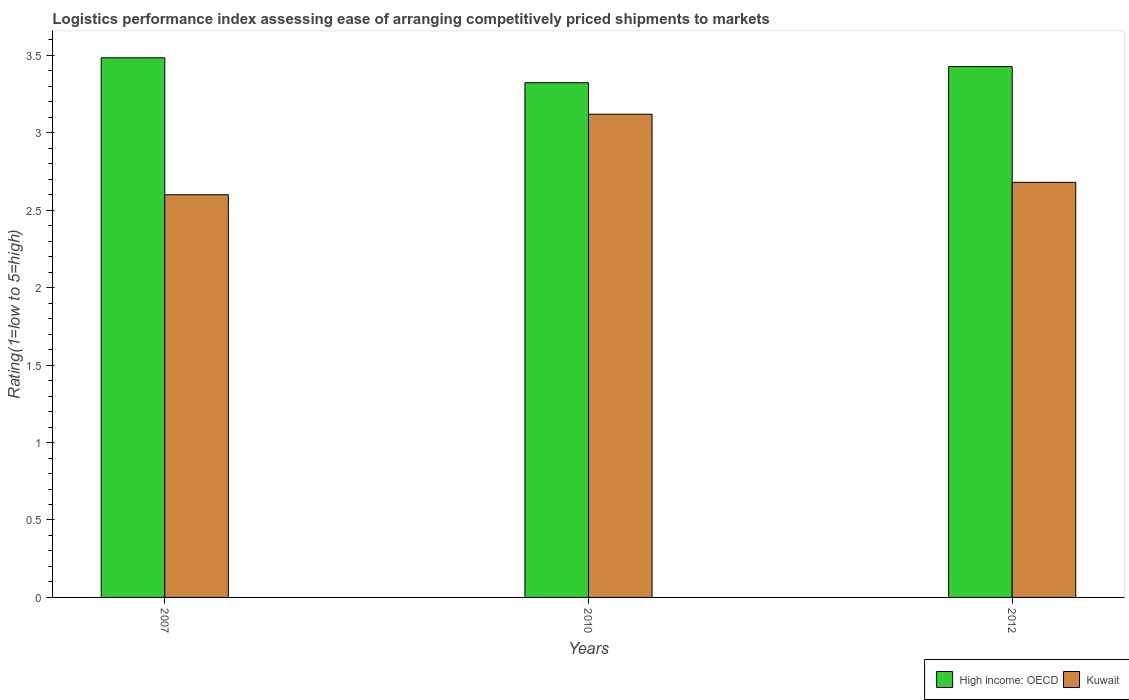How many different coloured bars are there?
Make the answer very short. 2. How many groups of bars are there?
Provide a succinct answer. 3. How many bars are there on the 2nd tick from the left?
Your answer should be compact. 2. How many bars are there on the 3rd tick from the right?
Ensure brevity in your answer.  2. In how many cases, is the number of bars for a given year not equal to the number of legend labels?
Your answer should be compact. 0. What is the Logistic performance index in High income: OECD in 2010?
Give a very brief answer. 3.32. Across all years, what is the maximum Logistic performance index in Kuwait?
Your answer should be very brief. 3.12. Across all years, what is the minimum Logistic performance index in High income: OECD?
Give a very brief answer. 3.32. In which year was the Logistic performance index in High income: OECD minimum?
Make the answer very short. 2010. What is the total Logistic performance index in High income: OECD in the graph?
Your response must be concise. 10.24. What is the difference between the Logistic performance index in High income: OECD in 2007 and that in 2012?
Your answer should be compact. 0.06. What is the difference between the Logistic performance index in High income: OECD in 2010 and the Logistic performance index in Kuwait in 2012?
Keep it short and to the point. 0.64. What is the average Logistic performance index in High income: OECD per year?
Make the answer very short. 3.41. In the year 2007, what is the difference between the Logistic performance index in Kuwait and Logistic performance index in High income: OECD?
Give a very brief answer. -0.88. In how many years, is the Logistic performance index in Kuwait greater than 2.5?
Offer a very short reply. 3. What is the ratio of the Logistic performance index in High income: OECD in 2010 to that in 2012?
Provide a short and direct response. 0.97. Is the Logistic performance index in High income: OECD in 2010 less than that in 2012?
Keep it short and to the point. Yes. What is the difference between the highest and the second highest Logistic performance index in Kuwait?
Make the answer very short. 0.44. What is the difference between the highest and the lowest Logistic performance index in Kuwait?
Offer a terse response. 0.52. In how many years, is the Logistic performance index in High income: OECD greater than the average Logistic performance index in High income: OECD taken over all years?
Provide a succinct answer. 2. Is the sum of the Logistic performance index in High income: OECD in 2010 and 2012 greater than the maximum Logistic performance index in Kuwait across all years?
Ensure brevity in your answer.  Yes. What does the 1st bar from the left in 2012 represents?
Your answer should be very brief. High income: OECD. What does the 1st bar from the right in 2010 represents?
Offer a terse response. Kuwait. How many bars are there?
Make the answer very short. 6. Does the graph contain any zero values?
Make the answer very short. No. Does the graph contain grids?
Offer a very short reply. No. Where does the legend appear in the graph?
Your answer should be compact. Bottom right. What is the title of the graph?
Make the answer very short. Logistics performance index assessing ease of arranging competitively priced shipments to markets. Does "Congo (Republic)" appear as one of the legend labels in the graph?
Make the answer very short. No. What is the label or title of the Y-axis?
Your answer should be compact. Rating(1=low to 5=high). What is the Rating(1=low to 5=high) of High income: OECD in 2007?
Offer a very short reply. 3.48. What is the Rating(1=low to 5=high) in High income: OECD in 2010?
Provide a short and direct response. 3.32. What is the Rating(1=low to 5=high) in Kuwait in 2010?
Ensure brevity in your answer.  3.12. What is the Rating(1=low to 5=high) of High income: OECD in 2012?
Ensure brevity in your answer.  3.43. What is the Rating(1=low to 5=high) of Kuwait in 2012?
Your answer should be compact. 2.68. Across all years, what is the maximum Rating(1=low to 5=high) in High income: OECD?
Your answer should be very brief. 3.48. Across all years, what is the maximum Rating(1=low to 5=high) of Kuwait?
Make the answer very short. 3.12. Across all years, what is the minimum Rating(1=low to 5=high) of High income: OECD?
Make the answer very short. 3.32. Across all years, what is the minimum Rating(1=low to 5=high) of Kuwait?
Offer a very short reply. 2.6. What is the total Rating(1=low to 5=high) in High income: OECD in the graph?
Offer a terse response. 10.24. What is the difference between the Rating(1=low to 5=high) of High income: OECD in 2007 and that in 2010?
Ensure brevity in your answer.  0.16. What is the difference between the Rating(1=low to 5=high) of Kuwait in 2007 and that in 2010?
Offer a very short reply. -0.52. What is the difference between the Rating(1=low to 5=high) in High income: OECD in 2007 and that in 2012?
Keep it short and to the point. 0.06. What is the difference between the Rating(1=low to 5=high) of Kuwait in 2007 and that in 2012?
Offer a very short reply. -0.08. What is the difference between the Rating(1=low to 5=high) of High income: OECD in 2010 and that in 2012?
Provide a succinct answer. -0.1. What is the difference between the Rating(1=low to 5=high) in Kuwait in 2010 and that in 2012?
Offer a very short reply. 0.44. What is the difference between the Rating(1=low to 5=high) in High income: OECD in 2007 and the Rating(1=low to 5=high) in Kuwait in 2010?
Provide a succinct answer. 0.36. What is the difference between the Rating(1=low to 5=high) in High income: OECD in 2007 and the Rating(1=low to 5=high) in Kuwait in 2012?
Provide a succinct answer. 0.8. What is the difference between the Rating(1=low to 5=high) of High income: OECD in 2010 and the Rating(1=low to 5=high) of Kuwait in 2012?
Offer a terse response. 0.64. What is the average Rating(1=low to 5=high) in High income: OECD per year?
Make the answer very short. 3.41. In the year 2007, what is the difference between the Rating(1=low to 5=high) of High income: OECD and Rating(1=low to 5=high) of Kuwait?
Your response must be concise. 0.88. In the year 2010, what is the difference between the Rating(1=low to 5=high) in High income: OECD and Rating(1=low to 5=high) in Kuwait?
Make the answer very short. 0.2. In the year 2012, what is the difference between the Rating(1=low to 5=high) in High income: OECD and Rating(1=low to 5=high) in Kuwait?
Ensure brevity in your answer.  0.75. What is the ratio of the Rating(1=low to 5=high) in High income: OECD in 2007 to that in 2010?
Give a very brief answer. 1.05. What is the ratio of the Rating(1=low to 5=high) of Kuwait in 2007 to that in 2010?
Keep it short and to the point. 0.83. What is the ratio of the Rating(1=low to 5=high) in High income: OECD in 2007 to that in 2012?
Make the answer very short. 1.02. What is the ratio of the Rating(1=low to 5=high) in Kuwait in 2007 to that in 2012?
Your answer should be very brief. 0.97. What is the ratio of the Rating(1=low to 5=high) in High income: OECD in 2010 to that in 2012?
Give a very brief answer. 0.97. What is the ratio of the Rating(1=low to 5=high) of Kuwait in 2010 to that in 2012?
Give a very brief answer. 1.16. What is the difference between the highest and the second highest Rating(1=low to 5=high) in High income: OECD?
Offer a very short reply. 0.06. What is the difference between the highest and the second highest Rating(1=low to 5=high) in Kuwait?
Your answer should be compact. 0.44. What is the difference between the highest and the lowest Rating(1=low to 5=high) of High income: OECD?
Offer a very short reply. 0.16. What is the difference between the highest and the lowest Rating(1=low to 5=high) in Kuwait?
Offer a very short reply. 0.52. 